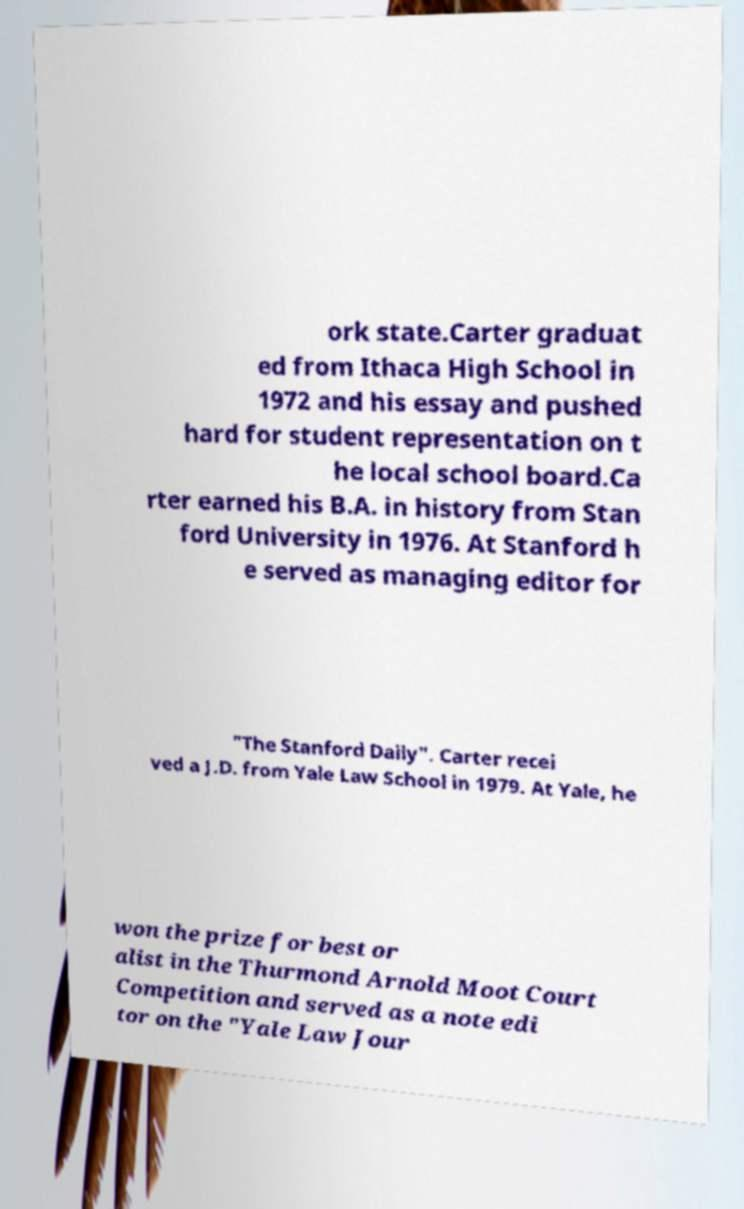Could you extract and type out the text from this image? ork state.Carter graduat ed from Ithaca High School in 1972 and his essay and pushed hard for student representation on t he local school board.Ca rter earned his B.A. in history from Stan ford University in 1976. At Stanford h e served as managing editor for "The Stanford Daily". Carter recei ved a J.D. from Yale Law School in 1979. At Yale, he won the prize for best or alist in the Thurmond Arnold Moot Court Competition and served as a note edi tor on the "Yale Law Jour 